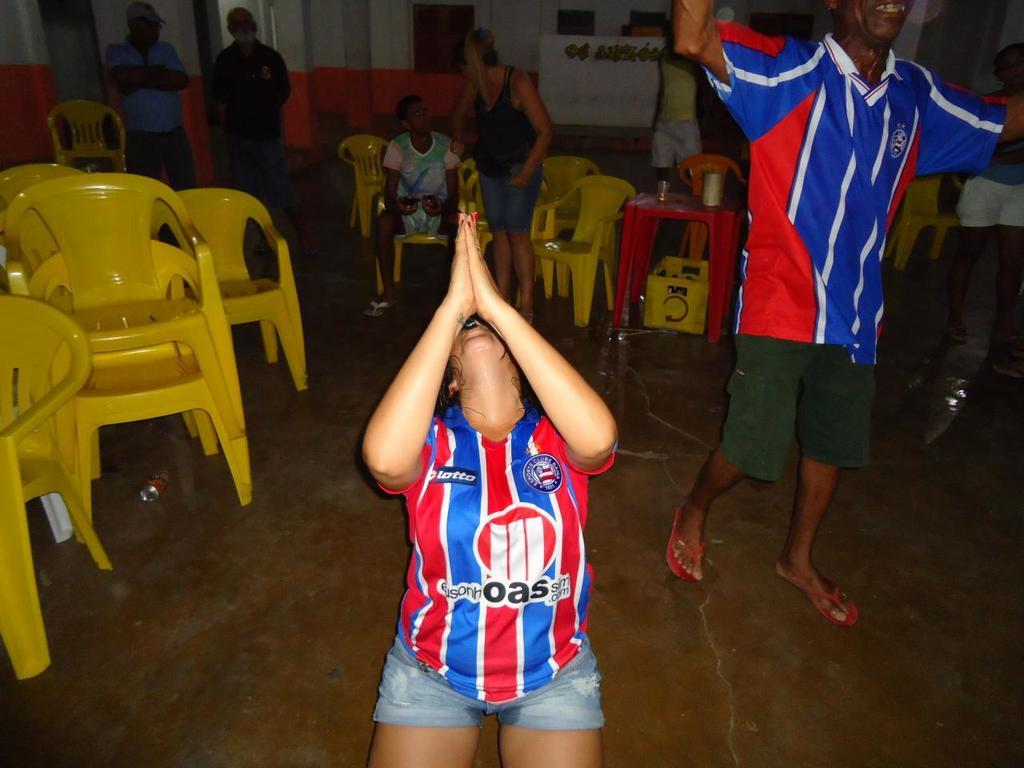<image>
Share a concise interpretation of the image provided. C Lotto is in the upper right hand side of the red and blue shirt. 